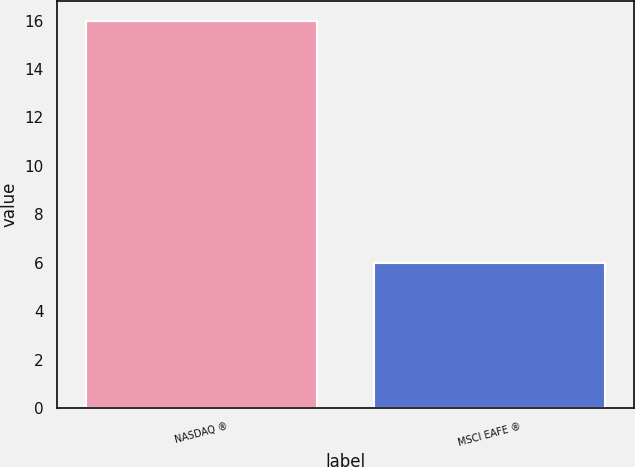Convert chart. <chart><loc_0><loc_0><loc_500><loc_500><bar_chart><fcel>NASDAQ ®<fcel>MSCI EAFE ®<nl><fcel>16<fcel>6<nl></chart> 